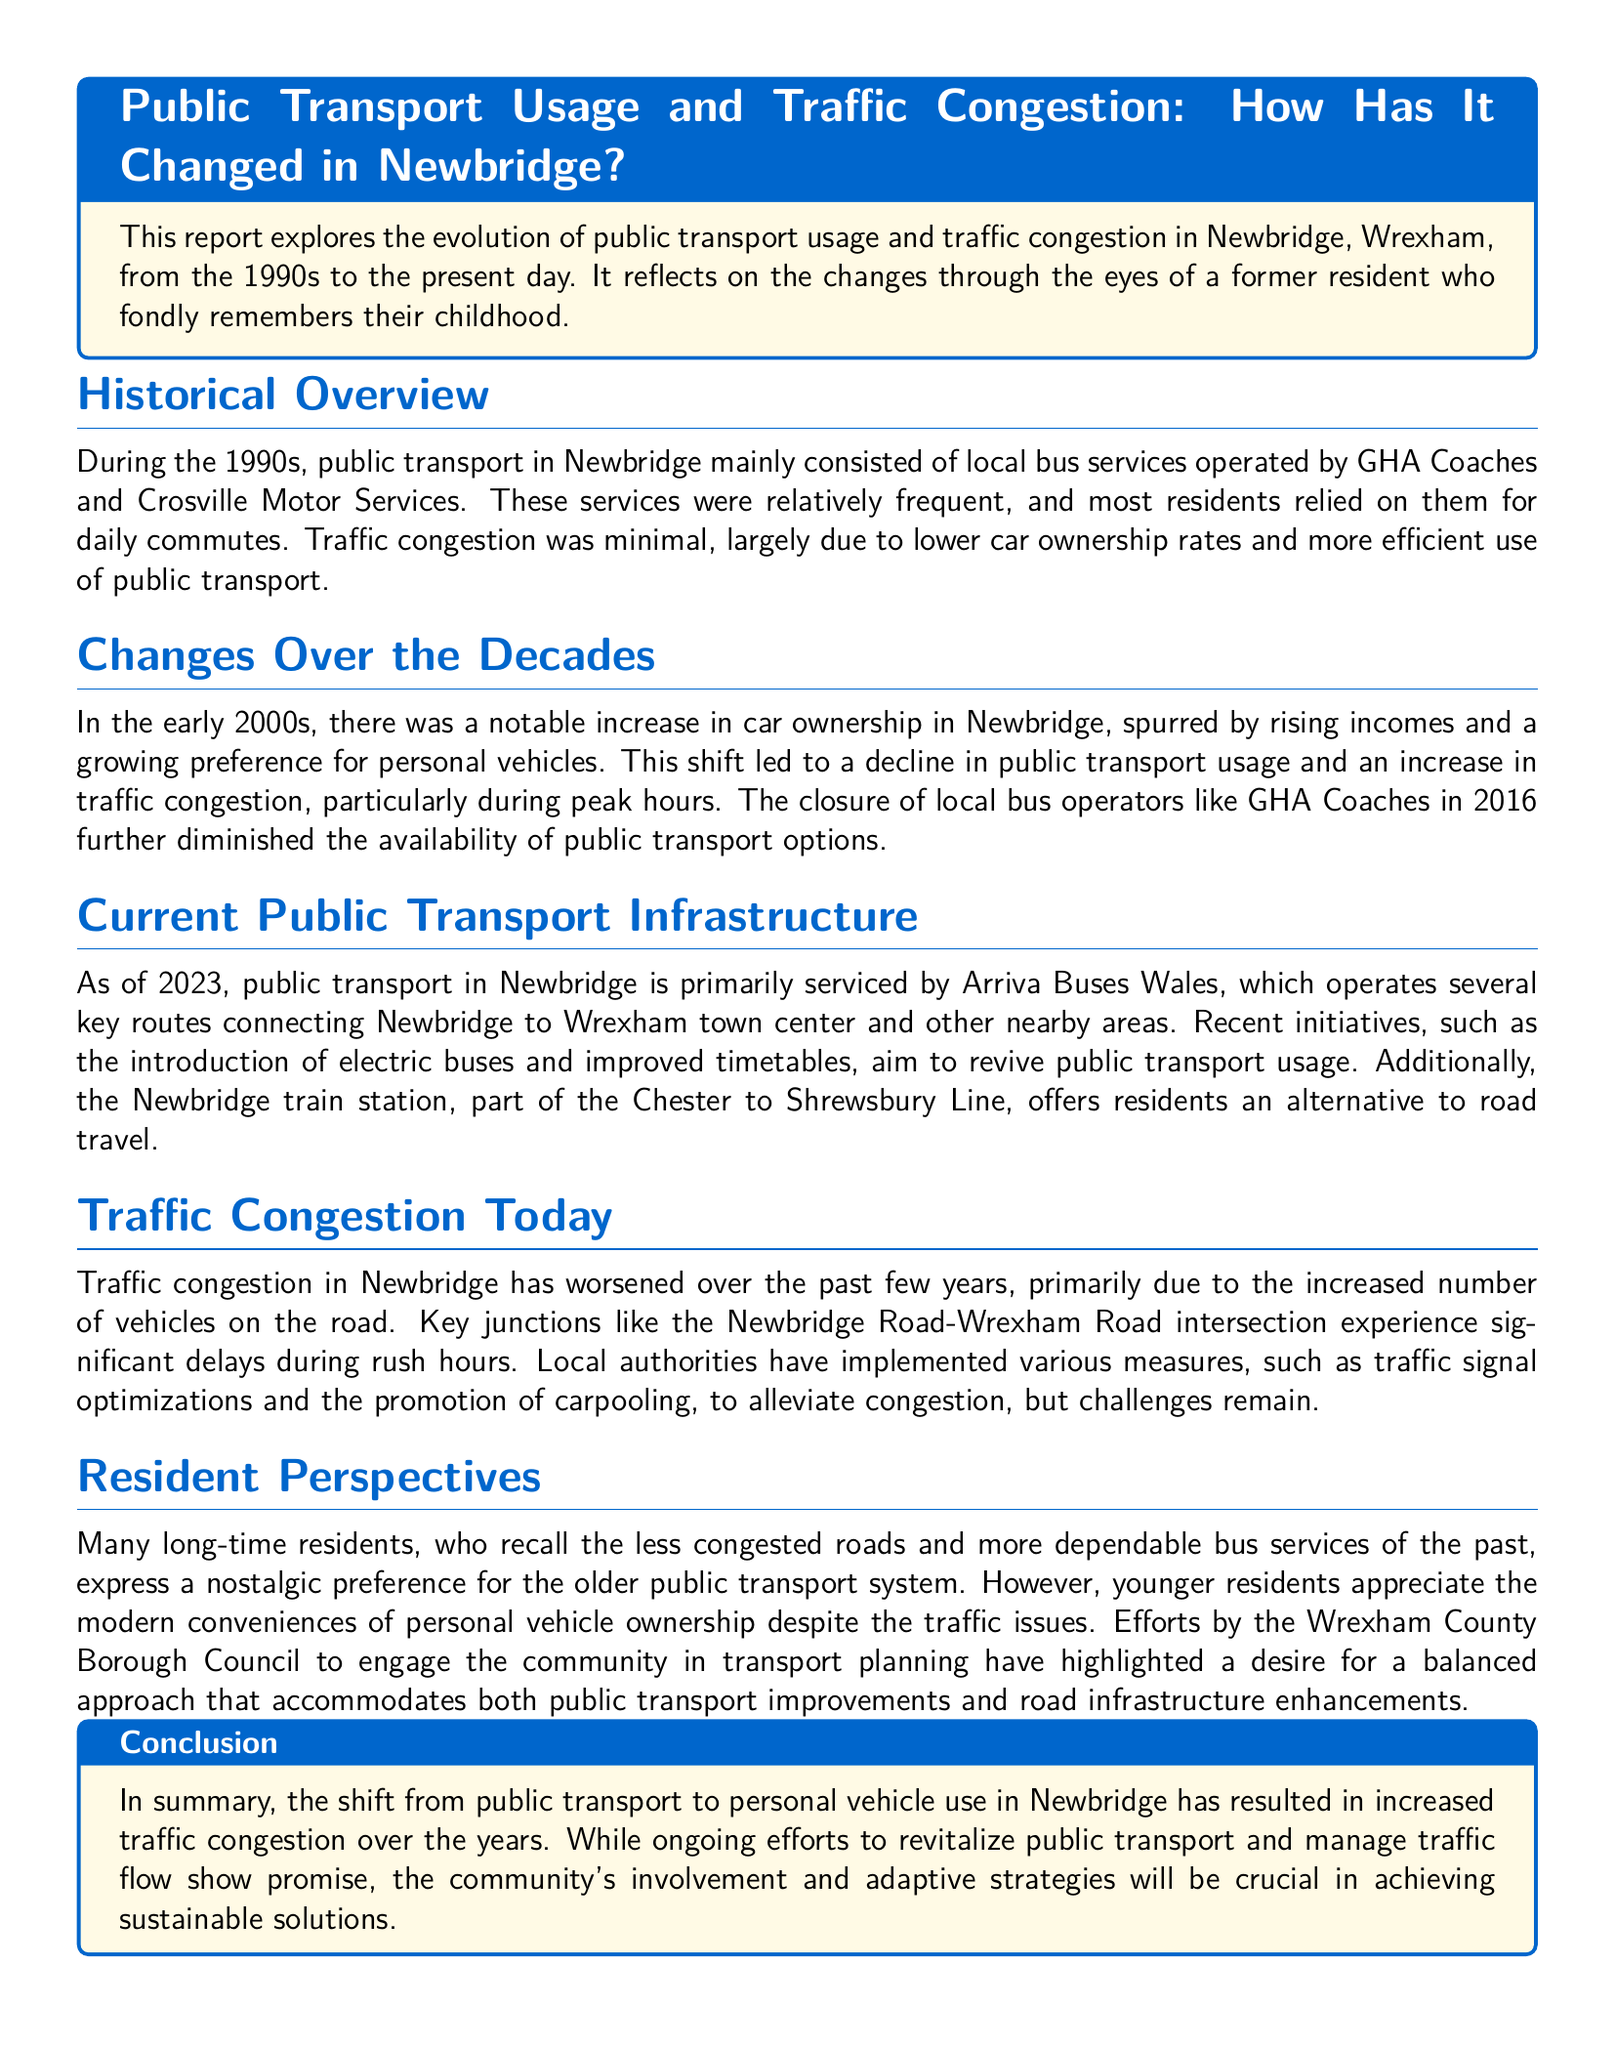What local bus services operated in the 1990s? The document states that local bus services in the 1990s were operated by GHA Coaches and Crosville Motor Services.
Answer: GHA Coaches and Crosville Motor Services What significant change occurred in the early 2000s regarding vehicle ownership? The report indicates that there was a notable increase in car ownership in Newbridge due to rising incomes and a growing preference for personal vehicles.
Answer: Increased car ownership What year did GHA Coaches close? According to the document, GHA Coaches closed in 2016.
Answer: 2016 How many key routes does Arriva Buses Wales operate as of 2023? The document mentions that Arriva Buses Wales operates several key routes, but it does not specify an exact number.
Answer: Several What measures have local authorities implemented to alleviate congestion? The report mentions traffic signal optimizations and the promotion of carpooling as measures taken to alleviate congestion.
Answer: Traffic signal optimizations and carpooling Why do many long-time residents prefer the older public transport system? The document suggests that long-time residents remember less congested roads and more dependable bus services from the past, influencing their preference.
Answer: Nostalgia for less congestion and dependable services What transportation alternative is mentioned besides buses? The report indicates that the Newbridge train station offers residents an alternative to road travel.
Answer: Newbridge train station What approach do residents desire for future transport planning? The document highlights a desire for a balanced approach that accommodates both public transport improvements and road infrastructure enhancements.
Answer: Balanced approach What is the primary conclusion of the report? The conclusion states that the shift from public transport to personal vehicle use has resulted in increased traffic congestion over the years.
Answer: Increased traffic congestion 